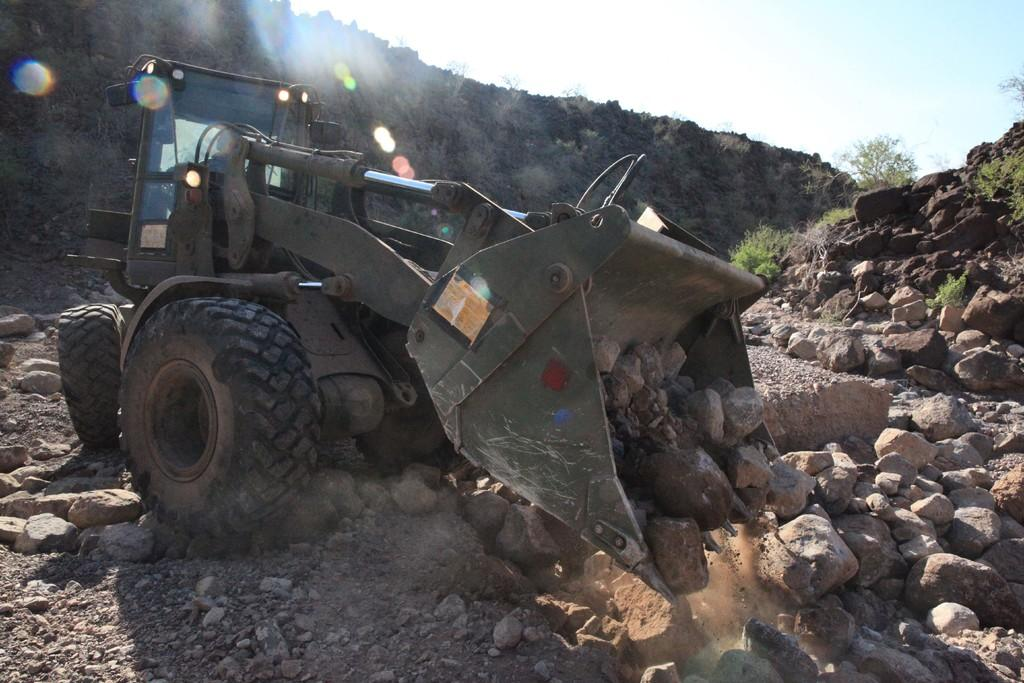What is the main subject in the center of the image? There is a vehicle in the center of the image. What type of objects can be seen on the ground in the image? There are stones in the image. What can be seen in the background of the image? There are rocks and trees in the background of the image. What type of trousers are the trees wearing in the image? Trees do not wear trousers, as they are not human or capable of wearing clothing. 